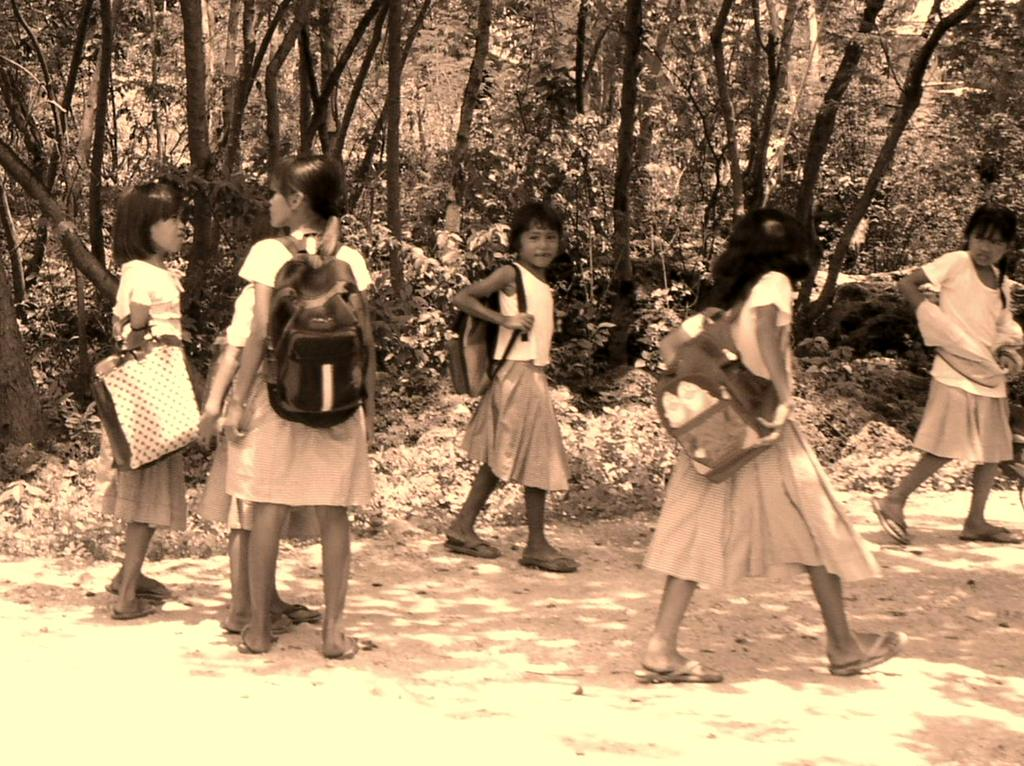What can be seen in the image? There are kids in the image. What are the kids wearing? The kids are wearing bags. What can be observed on the path in the image? There are shadows of objects on the path. What is visible in the background of the image? There are plants and trees in the background of the image. What type of fire can be seen in the image? There is no fire present in the image. How is the connection between the kids established in the image? The image does not show any direct connection between the kids; they are simply present in the same scene. 